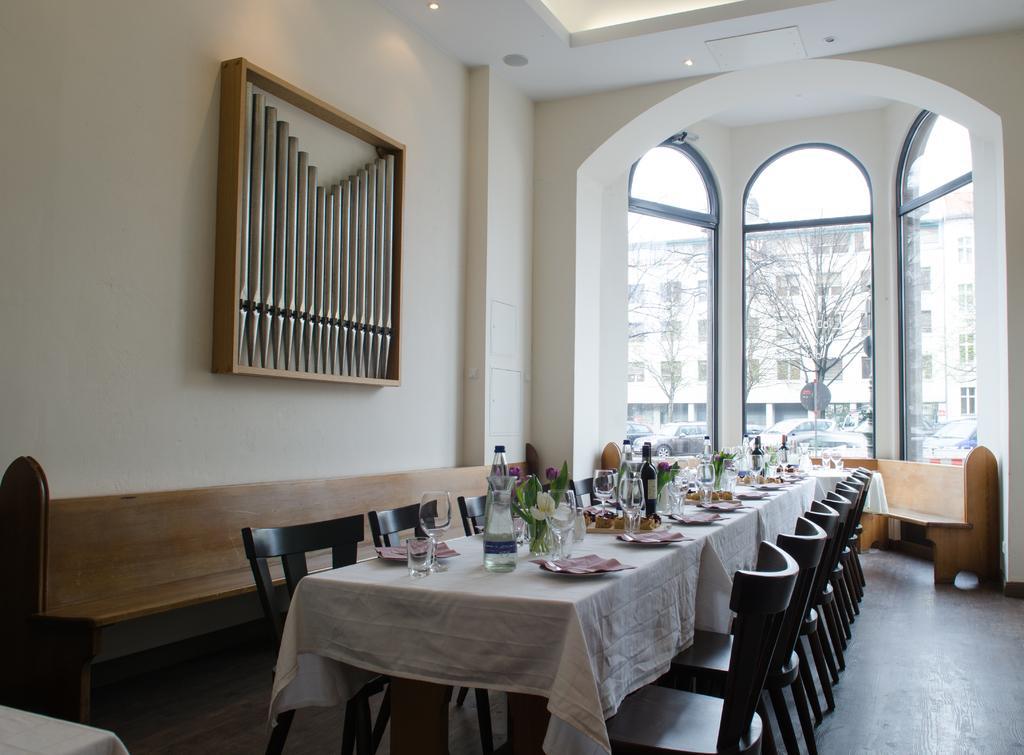In one or two sentences, can you explain what this image depicts? In this image, in the middle, we can see some tables and chairs. On that table, we can see some white color, some glasses, plate, water bottle, flower pot, plant, flowers. On the left side, we can see a bench. On the right side, we can also see another bench. On the left side, we can see a wood frame which is attached to a wall. In the background, we can see a glass window, outside of the glass window, we can see a tree and a building. 